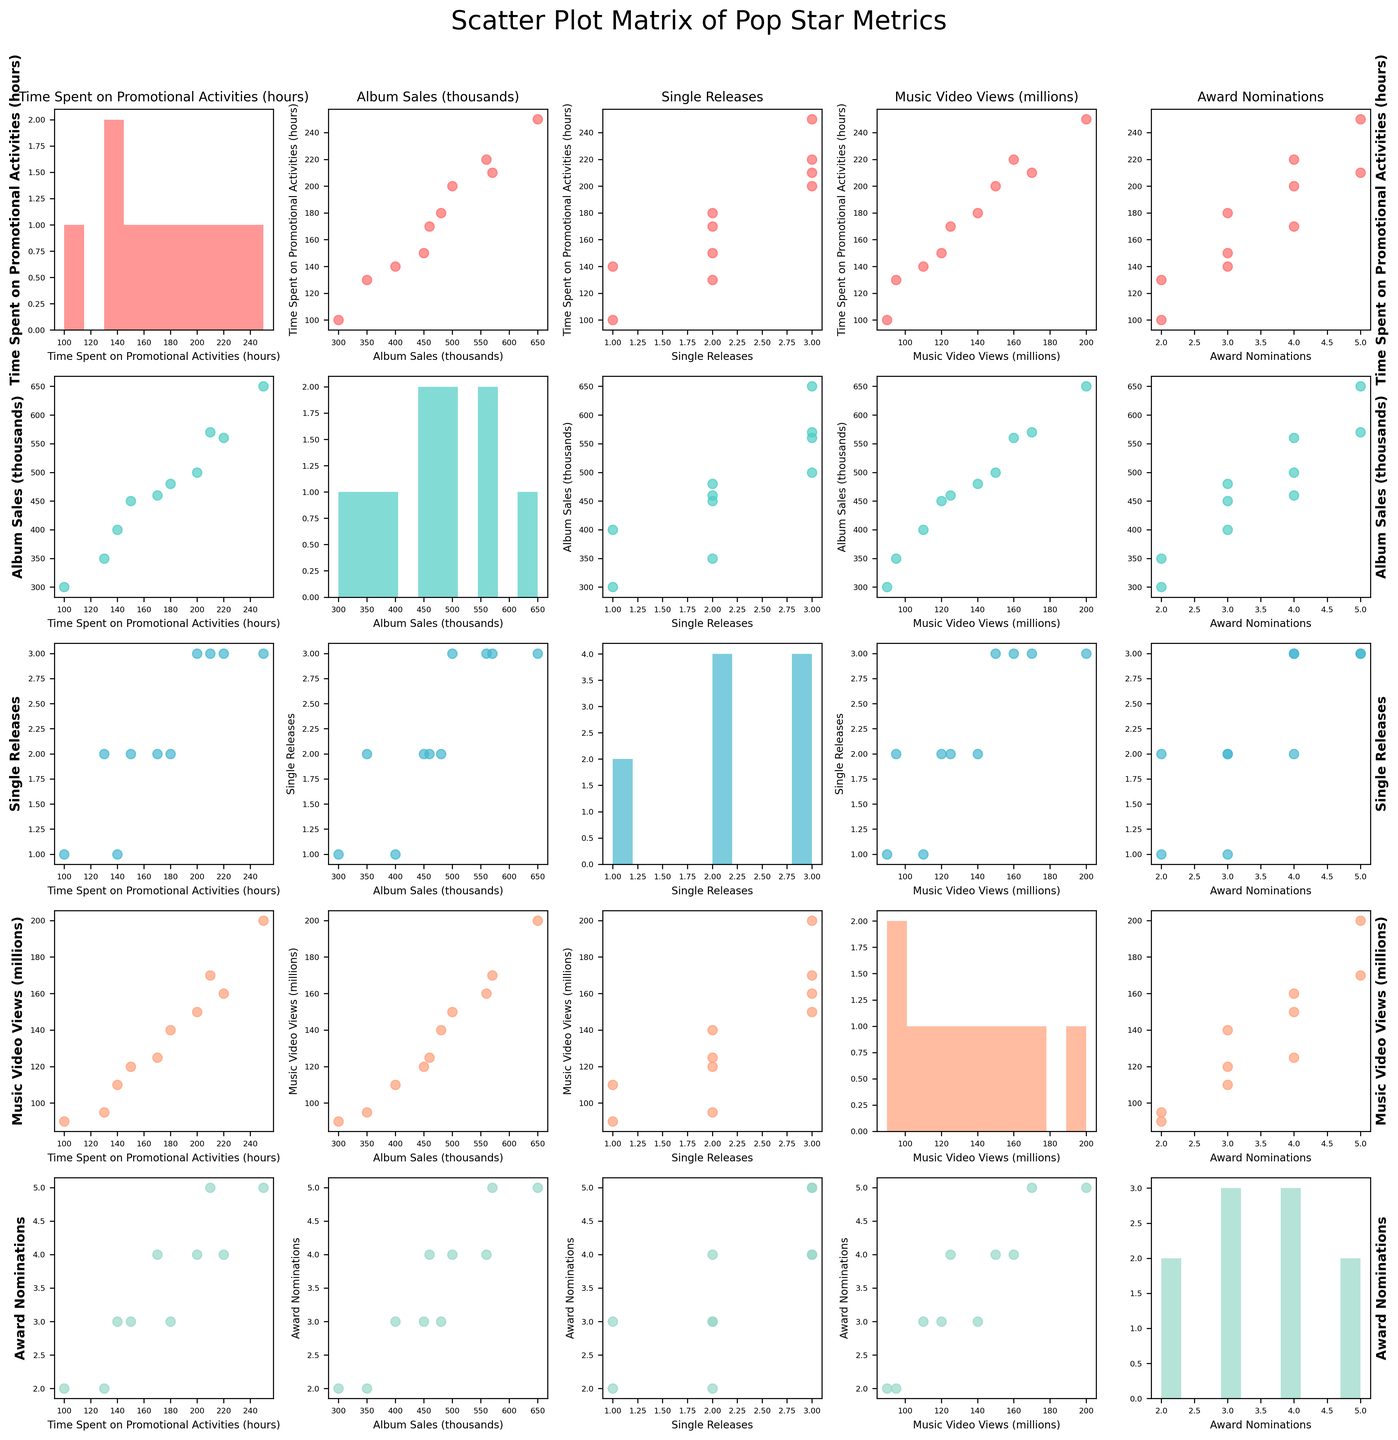what is the title of the figure? Look at the top center of the plot to find the title of the figure.
Answer: Scatter Plot Matrix of Pop Star Metrics How many data points are plotted in the scatter plot comparing Time Spent on Promotional Activities (hours) and Album Sales (thousands)? Count the number of points in the scatter plot located at the intersection of the "Time Spent on Promotional Activities (hours)" row and "Album Sales (thousands)" column.
Answer: 10 Which variable histogram has the highest peak in this SPLOM? Compare the heights of the peaks in all the histograms along the diagonal to determine which one is the highest.
Answer: Album Sales (thousands) Are there any outliers in the scatter plot comparing Time Spent on Promotional Activities (hours) and Music Video Views (millions)? Examine the scatter plot in the designated section for any points that are significantly distant from the others.
Answer: No Which plot shows a clear upward trend, the scatter plot of Time Spent on Promotional Activities vs. Music Video Views or Time Spent on Promotional Activities vs. Single Releases? Compare the scatter plot rows of "Time Spent on Promotional Activities (hours)" with "Music Video Views (millions)" and "Single Releases" to assess the trend direction.
Answer: Promotional Activities vs. Music Video Views What is the median value in the histogram of Award Nominations? Analyze the histogram for "Award Nominations", arrange the data values from lowest to highest, and find the middle value.
Answer: 3 In which scatter plot are the points more tightly clustered, Time Spent on Promotional Activities vs. Album Sales or Album Sales vs. Award Nominations? Compare the scatter plots for "Time Spent on Promotional Activities (hours)" vs. "Album Sales (thousands)" and "Album Sales (thousands)" vs. "Award Nominations" to see where the points are closer together.
Answer: Album Sales vs. Award Nominations Do any scatter plots indicate a possible negative correlation among the variables? If so, which ones? Examine all scatter plots for patterns where an increase in one variable corresponds to a decrease in another variable.
Answer: None What is the range of Music Video Views (millions) based on its histogram? Look at the histogram for "Music Video Views (millions)" and note the minimum and maximum values along the x-axis. Compute the range by subtracting the minimum from the maximum.
Answer: 110 Which two variables have the most similar distribution based on their histograms? Compare the shapes of the histograms for all variables to identify which two look the most alike in terms of peak, spread, and shape.
Answer: Time Spent on Promotional Activities and Music Video Views 